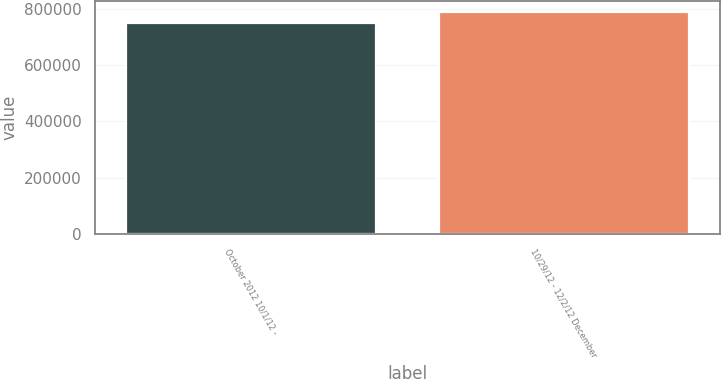<chart> <loc_0><loc_0><loc_500><loc_500><bar_chart><fcel>October 2012 10/1/12 -<fcel>10/29/12 - 12/2/12 December<nl><fcel>750000<fcel>787500<nl></chart> 